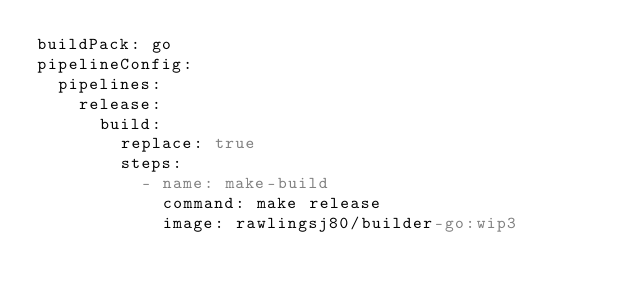Convert code to text. <code><loc_0><loc_0><loc_500><loc_500><_YAML_>buildPack: go
pipelineConfig:
  pipelines:
    release:
      build:
        replace: true
        steps:
          - name: make-build
            command: make release
            image: rawlingsj80/builder-go:wip3</code> 